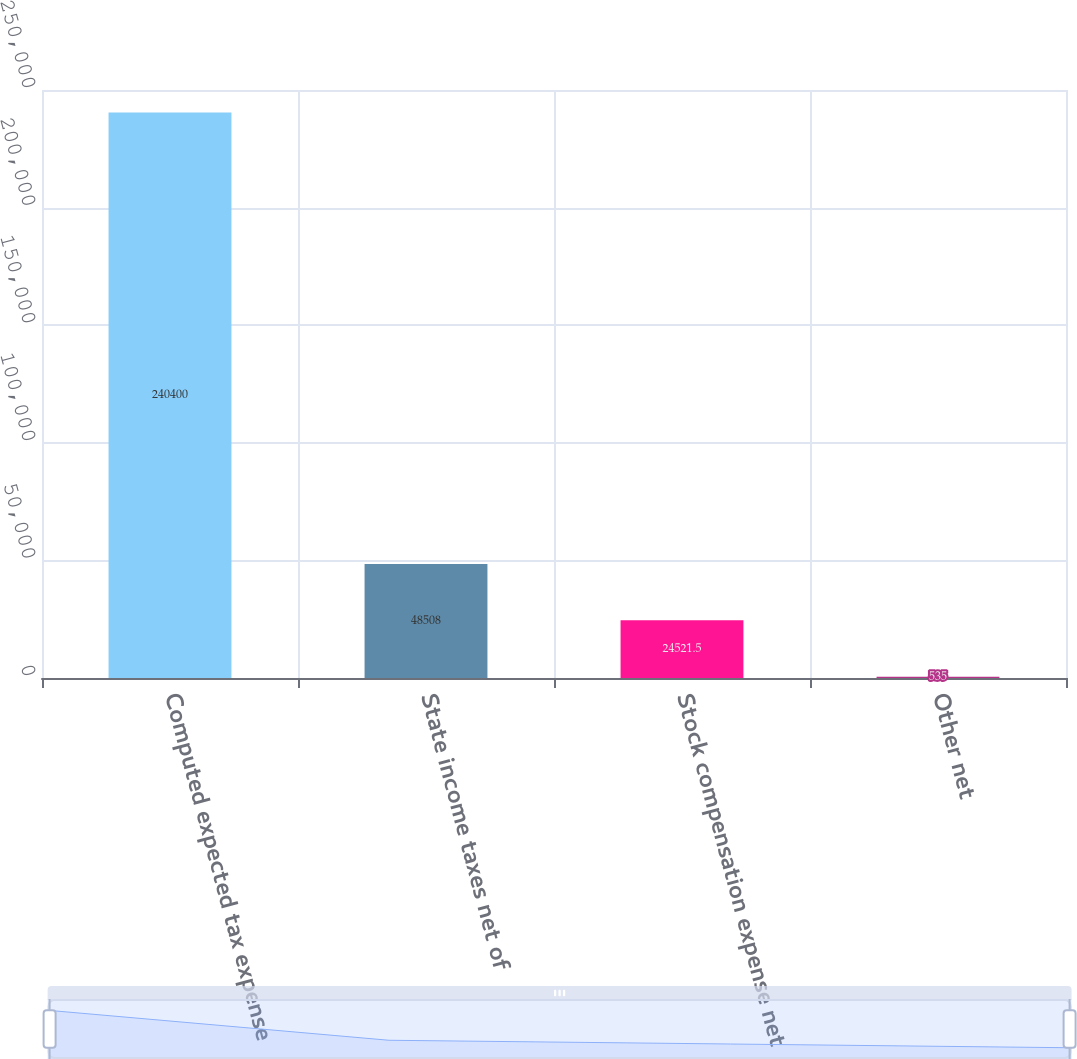Convert chart to OTSL. <chart><loc_0><loc_0><loc_500><loc_500><bar_chart><fcel>Computed expected tax expense<fcel>State income taxes net of<fcel>Stock compensation expense net<fcel>Other net<nl><fcel>240400<fcel>48508<fcel>24521.5<fcel>535<nl></chart> 